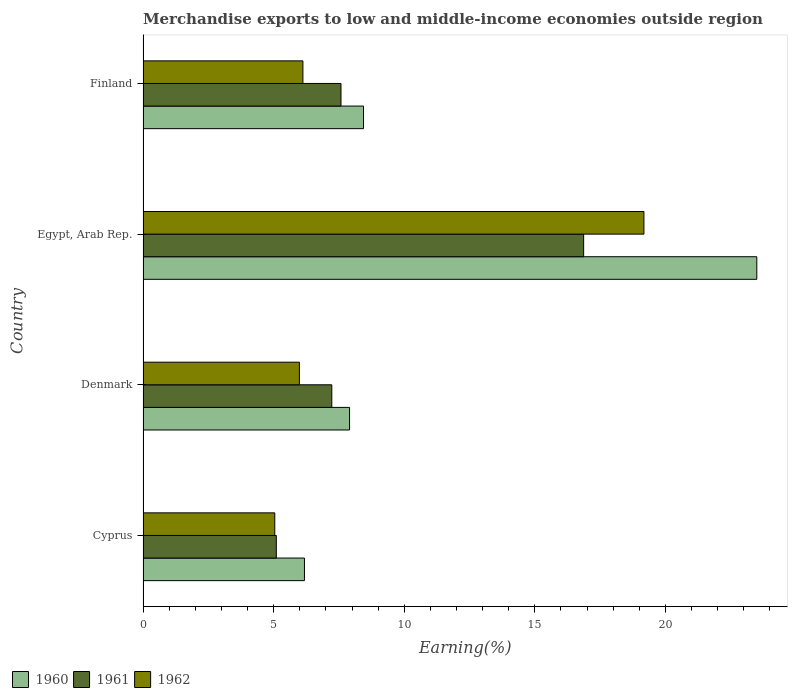How many different coloured bars are there?
Provide a short and direct response. 3. What is the label of the 2nd group of bars from the top?
Provide a succinct answer. Egypt, Arab Rep. In how many cases, is the number of bars for a given country not equal to the number of legend labels?
Make the answer very short. 0. What is the percentage of amount earned from merchandise exports in 1962 in Cyprus?
Provide a succinct answer. 5.04. Across all countries, what is the maximum percentage of amount earned from merchandise exports in 1962?
Your answer should be very brief. 19.18. Across all countries, what is the minimum percentage of amount earned from merchandise exports in 1961?
Provide a succinct answer. 5.1. In which country was the percentage of amount earned from merchandise exports in 1962 maximum?
Offer a very short reply. Egypt, Arab Rep. In which country was the percentage of amount earned from merchandise exports in 1960 minimum?
Offer a terse response. Cyprus. What is the total percentage of amount earned from merchandise exports in 1961 in the graph?
Your answer should be compact. 36.78. What is the difference between the percentage of amount earned from merchandise exports in 1960 in Denmark and that in Egypt, Arab Rep.?
Your answer should be compact. -15.59. What is the difference between the percentage of amount earned from merchandise exports in 1960 in Cyprus and the percentage of amount earned from merchandise exports in 1961 in Egypt, Arab Rep.?
Your answer should be very brief. -10.69. What is the average percentage of amount earned from merchandise exports in 1962 per country?
Give a very brief answer. 9.08. What is the difference between the percentage of amount earned from merchandise exports in 1960 and percentage of amount earned from merchandise exports in 1961 in Finland?
Your response must be concise. 0.86. What is the ratio of the percentage of amount earned from merchandise exports in 1962 in Cyprus to that in Finland?
Give a very brief answer. 0.82. What is the difference between the highest and the second highest percentage of amount earned from merchandise exports in 1960?
Provide a short and direct response. 15.06. What is the difference between the highest and the lowest percentage of amount earned from merchandise exports in 1962?
Provide a succinct answer. 14.14. Is it the case that in every country, the sum of the percentage of amount earned from merchandise exports in 1961 and percentage of amount earned from merchandise exports in 1960 is greater than the percentage of amount earned from merchandise exports in 1962?
Your answer should be very brief. Yes. How many countries are there in the graph?
Keep it short and to the point. 4. Does the graph contain grids?
Keep it short and to the point. No. Where does the legend appear in the graph?
Provide a short and direct response. Bottom left. What is the title of the graph?
Make the answer very short. Merchandise exports to low and middle-income economies outside region. Does "1998" appear as one of the legend labels in the graph?
Provide a succinct answer. No. What is the label or title of the X-axis?
Offer a terse response. Earning(%). What is the label or title of the Y-axis?
Keep it short and to the point. Country. What is the Earning(%) of 1960 in Cyprus?
Ensure brevity in your answer.  6.18. What is the Earning(%) of 1961 in Cyprus?
Your answer should be very brief. 5.1. What is the Earning(%) of 1962 in Cyprus?
Offer a terse response. 5.04. What is the Earning(%) of 1960 in Denmark?
Provide a succinct answer. 7.91. What is the Earning(%) in 1961 in Denmark?
Your response must be concise. 7.23. What is the Earning(%) in 1962 in Denmark?
Give a very brief answer. 5.99. What is the Earning(%) of 1960 in Egypt, Arab Rep.?
Keep it short and to the point. 23.5. What is the Earning(%) of 1961 in Egypt, Arab Rep.?
Provide a succinct answer. 16.87. What is the Earning(%) in 1962 in Egypt, Arab Rep.?
Give a very brief answer. 19.18. What is the Earning(%) of 1960 in Finland?
Your answer should be compact. 8.44. What is the Earning(%) in 1961 in Finland?
Give a very brief answer. 7.58. What is the Earning(%) of 1962 in Finland?
Provide a succinct answer. 6.12. Across all countries, what is the maximum Earning(%) of 1960?
Ensure brevity in your answer.  23.5. Across all countries, what is the maximum Earning(%) in 1961?
Provide a succinct answer. 16.87. Across all countries, what is the maximum Earning(%) in 1962?
Offer a terse response. 19.18. Across all countries, what is the minimum Earning(%) of 1960?
Keep it short and to the point. 6.18. Across all countries, what is the minimum Earning(%) of 1961?
Make the answer very short. 5.1. Across all countries, what is the minimum Earning(%) in 1962?
Provide a short and direct response. 5.04. What is the total Earning(%) of 1960 in the graph?
Ensure brevity in your answer.  46.03. What is the total Earning(%) of 1961 in the graph?
Ensure brevity in your answer.  36.78. What is the total Earning(%) of 1962 in the graph?
Keep it short and to the point. 36.33. What is the difference between the Earning(%) in 1960 in Cyprus and that in Denmark?
Offer a terse response. -1.73. What is the difference between the Earning(%) of 1961 in Cyprus and that in Denmark?
Your answer should be very brief. -2.12. What is the difference between the Earning(%) of 1962 in Cyprus and that in Denmark?
Your answer should be very brief. -0.94. What is the difference between the Earning(%) in 1960 in Cyprus and that in Egypt, Arab Rep.?
Ensure brevity in your answer.  -17.32. What is the difference between the Earning(%) of 1961 in Cyprus and that in Egypt, Arab Rep.?
Provide a succinct answer. -11.77. What is the difference between the Earning(%) of 1962 in Cyprus and that in Egypt, Arab Rep.?
Keep it short and to the point. -14.14. What is the difference between the Earning(%) of 1960 in Cyprus and that in Finland?
Provide a succinct answer. -2.26. What is the difference between the Earning(%) of 1961 in Cyprus and that in Finland?
Keep it short and to the point. -2.48. What is the difference between the Earning(%) of 1962 in Cyprus and that in Finland?
Your answer should be compact. -1.08. What is the difference between the Earning(%) of 1960 in Denmark and that in Egypt, Arab Rep.?
Keep it short and to the point. -15.59. What is the difference between the Earning(%) of 1961 in Denmark and that in Egypt, Arab Rep.?
Offer a terse response. -9.64. What is the difference between the Earning(%) in 1962 in Denmark and that in Egypt, Arab Rep.?
Make the answer very short. -13.19. What is the difference between the Earning(%) of 1960 in Denmark and that in Finland?
Your response must be concise. -0.53. What is the difference between the Earning(%) of 1961 in Denmark and that in Finland?
Keep it short and to the point. -0.35. What is the difference between the Earning(%) in 1962 in Denmark and that in Finland?
Offer a terse response. -0.13. What is the difference between the Earning(%) of 1960 in Egypt, Arab Rep. and that in Finland?
Provide a short and direct response. 15.06. What is the difference between the Earning(%) in 1961 in Egypt, Arab Rep. and that in Finland?
Ensure brevity in your answer.  9.29. What is the difference between the Earning(%) of 1962 in Egypt, Arab Rep. and that in Finland?
Your response must be concise. 13.06. What is the difference between the Earning(%) in 1960 in Cyprus and the Earning(%) in 1961 in Denmark?
Give a very brief answer. -1.05. What is the difference between the Earning(%) in 1960 in Cyprus and the Earning(%) in 1962 in Denmark?
Ensure brevity in your answer.  0.19. What is the difference between the Earning(%) of 1961 in Cyprus and the Earning(%) of 1962 in Denmark?
Your answer should be compact. -0.88. What is the difference between the Earning(%) in 1960 in Cyprus and the Earning(%) in 1961 in Egypt, Arab Rep.?
Your response must be concise. -10.69. What is the difference between the Earning(%) in 1960 in Cyprus and the Earning(%) in 1962 in Egypt, Arab Rep.?
Keep it short and to the point. -13. What is the difference between the Earning(%) in 1961 in Cyprus and the Earning(%) in 1962 in Egypt, Arab Rep.?
Keep it short and to the point. -14.08. What is the difference between the Earning(%) of 1960 in Cyprus and the Earning(%) of 1961 in Finland?
Keep it short and to the point. -1.4. What is the difference between the Earning(%) of 1960 in Cyprus and the Earning(%) of 1962 in Finland?
Provide a short and direct response. 0.06. What is the difference between the Earning(%) of 1961 in Cyprus and the Earning(%) of 1962 in Finland?
Offer a very short reply. -1.02. What is the difference between the Earning(%) of 1960 in Denmark and the Earning(%) of 1961 in Egypt, Arab Rep.?
Provide a succinct answer. -8.96. What is the difference between the Earning(%) in 1960 in Denmark and the Earning(%) in 1962 in Egypt, Arab Rep.?
Give a very brief answer. -11.27. What is the difference between the Earning(%) in 1961 in Denmark and the Earning(%) in 1962 in Egypt, Arab Rep.?
Provide a succinct answer. -11.95. What is the difference between the Earning(%) in 1960 in Denmark and the Earning(%) in 1961 in Finland?
Keep it short and to the point. 0.33. What is the difference between the Earning(%) in 1960 in Denmark and the Earning(%) in 1962 in Finland?
Offer a terse response. 1.79. What is the difference between the Earning(%) of 1961 in Denmark and the Earning(%) of 1962 in Finland?
Your response must be concise. 1.11. What is the difference between the Earning(%) of 1960 in Egypt, Arab Rep. and the Earning(%) of 1961 in Finland?
Ensure brevity in your answer.  15.92. What is the difference between the Earning(%) in 1960 in Egypt, Arab Rep. and the Earning(%) in 1962 in Finland?
Provide a short and direct response. 17.38. What is the difference between the Earning(%) in 1961 in Egypt, Arab Rep. and the Earning(%) in 1962 in Finland?
Your response must be concise. 10.75. What is the average Earning(%) in 1960 per country?
Keep it short and to the point. 11.51. What is the average Earning(%) in 1961 per country?
Your response must be concise. 9.19. What is the average Earning(%) in 1962 per country?
Provide a short and direct response. 9.08. What is the difference between the Earning(%) of 1960 and Earning(%) of 1961 in Cyprus?
Provide a short and direct response. 1.08. What is the difference between the Earning(%) in 1960 and Earning(%) in 1962 in Cyprus?
Keep it short and to the point. 1.14. What is the difference between the Earning(%) in 1961 and Earning(%) in 1962 in Cyprus?
Your answer should be compact. 0.06. What is the difference between the Earning(%) in 1960 and Earning(%) in 1961 in Denmark?
Your answer should be compact. 0.68. What is the difference between the Earning(%) in 1960 and Earning(%) in 1962 in Denmark?
Ensure brevity in your answer.  1.92. What is the difference between the Earning(%) of 1961 and Earning(%) of 1962 in Denmark?
Keep it short and to the point. 1.24. What is the difference between the Earning(%) in 1960 and Earning(%) in 1961 in Egypt, Arab Rep.?
Your answer should be compact. 6.63. What is the difference between the Earning(%) in 1960 and Earning(%) in 1962 in Egypt, Arab Rep.?
Keep it short and to the point. 4.32. What is the difference between the Earning(%) of 1961 and Earning(%) of 1962 in Egypt, Arab Rep.?
Ensure brevity in your answer.  -2.31. What is the difference between the Earning(%) of 1960 and Earning(%) of 1961 in Finland?
Offer a very short reply. 0.86. What is the difference between the Earning(%) of 1960 and Earning(%) of 1962 in Finland?
Your answer should be very brief. 2.32. What is the difference between the Earning(%) of 1961 and Earning(%) of 1962 in Finland?
Your answer should be very brief. 1.46. What is the ratio of the Earning(%) of 1960 in Cyprus to that in Denmark?
Offer a terse response. 0.78. What is the ratio of the Earning(%) in 1961 in Cyprus to that in Denmark?
Offer a very short reply. 0.71. What is the ratio of the Earning(%) of 1962 in Cyprus to that in Denmark?
Your response must be concise. 0.84. What is the ratio of the Earning(%) in 1960 in Cyprus to that in Egypt, Arab Rep.?
Provide a short and direct response. 0.26. What is the ratio of the Earning(%) of 1961 in Cyprus to that in Egypt, Arab Rep.?
Give a very brief answer. 0.3. What is the ratio of the Earning(%) of 1962 in Cyprus to that in Egypt, Arab Rep.?
Your answer should be compact. 0.26. What is the ratio of the Earning(%) in 1960 in Cyprus to that in Finland?
Provide a succinct answer. 0.73. What is the ratio of the Earning(%) in 1961 in Cyprus to that in Finland?
Give a very brief answer. 0.67. What is the ratio of the Earning(%) of 1962 in Cyprus to that in Finland?
Make the answer very short. 0.82. What is the ratio of the Earning(%) of 1960 in Denmark to that in Egypt, Arab Rep.?
Give a very brief answer. 0.34. What is the ratio of the Earning(%) in 1961 in Denmark to that in Egypt, Arab Rep.?
Offer a terse response. 0.43. What is the ratio of the Earning(%) of 1962 in Denmark to that in Egypt, Arab Rep.?
Provide a short and direct response. 0.31. What is the ratio of the Earning(%) in 1960 in Denmark to that in Finland?
Provide a short and direct response. 0.94. What is the ratio of the Earning(%) in 1961 in Denmark to that in Finland?
Provide a short and direct response. 0.95. What is the ratio of the Earning(%) of 1962 in Denmark to that in Finland?
Your answer should be compact. 0.98. What is the ratio of the Earning(%) in 1960 in Egypt, Arab Rep. to that in Finland?
Give a very brief answer. 2.78. What is the ratio of the Earning(%) of 1961 in Egypt, Arab Rep. to that in Finland?
Your answer should be compact. 2.23. What is the ratio of the Earning(%) in 1962 in Egypt, Arab Rep. to that in Finland?
Offer a very short reply. 3.13. What is the difference between the highest and the second highest Earning(%) in 1960?
Give a very brief answer. 15.06. What is the difference between the highest and the second highest Earning(%) of 1961?
Ensure brevity in your answer.  9.29. What is the difference between the highest and the second highest Earning(%) in 1962?
Give a very brief answer. 13.06. What is the difference between the highest and the lowest Earning(%) in 1960?
Offer a very short reply. 17.32. What is the difference between the highest and the lowest Earning(%) of 1961?
Give a very brief answer. 11.77. What is the difference between the highest and the lowest Earning(%) in 1962?
Your response must be concise. 14.14. 